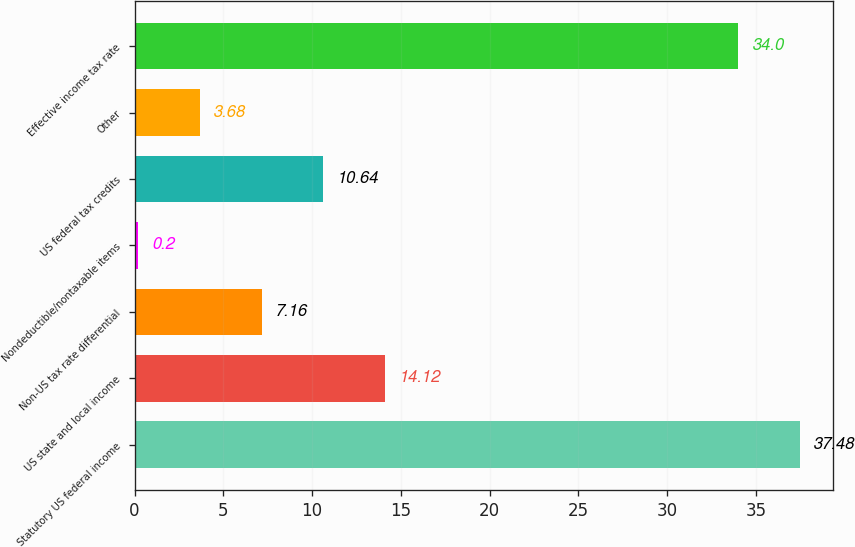Convert chart. <chart><loc_0><loc_0><loc_500><loc_500><bar_chart><fcel>Statutory US federal income<fcel>US state and local income<fcel>Non-US tax rate differential<fcel>Nondeductible/nontaxable items<fcel>US federal tax credits<fcel>Other<fcel>Effective income tax rate<nl><fcel>37.48<fcel>14.12<fcel>7.16<fcel>0.2<fcel>10.64<fcel>3.68<fcel>34<nl></chart> 